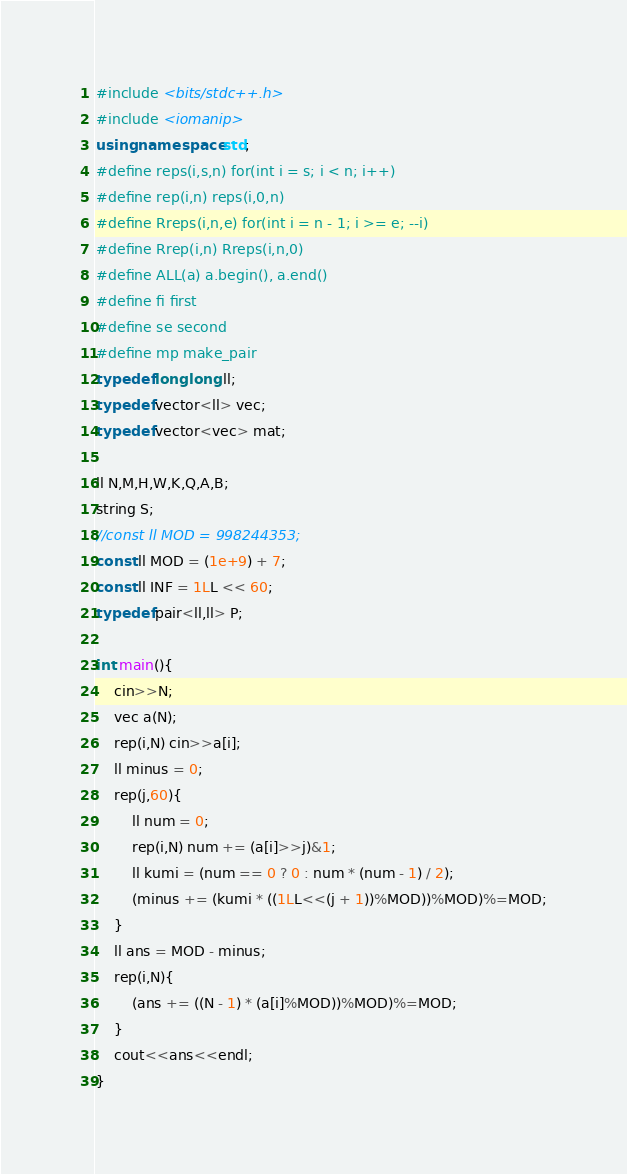<code> <loc_0><loc_0><loc_500><loc_500><_C++_>#include <bits/stdc++.h>
#include <iomanip>
using namespace std;
#define reps(i,s,n) for(int i = s; i < n; i++)
#define rep(i,n) reps(i,0,n)
#define Rreps(i,n,e) for(int i = n - 1; i >= e; --i)
#define Rrep(i,n) Rreps(i,n,0)
#define ALL(a) a.begin(), a.end()
#define fi first
#define se second
#define mp make_pair
typedef long long ll;
typedef vector<ll> vec;
typedef vector<vec> mat;

ll N,M,H,W,K,Q,A,B;
string S;
//const ll MOD = 998244353;
const ll MOD = (1e+9) + 7;
const ll INF = 1LL << 60;
typedef pair<ll,ll> P;

int main(){
    cin>>N;
    vec a(N);
    rep(i,N) cin>>a[i];
    ll minus = 0;
    rep(j,60){
        ll num = 0;
        rep(i,N) num += (a[i]>>j)&1;
        ll kumi = (num == 0 ? 0 : num * (num - 1) / 2);
        (minus += (kumi * ((1LL<<(j + 1))%MOD))%MOD)%=MOD;
    }
    ll ans = MOD - minus;
    rep(i,N){
        (ans += ((N - 1) * (a[i]%MOD))%MOD)%=MOD;
    }
    cout<<ans<<endl;
}</code> 